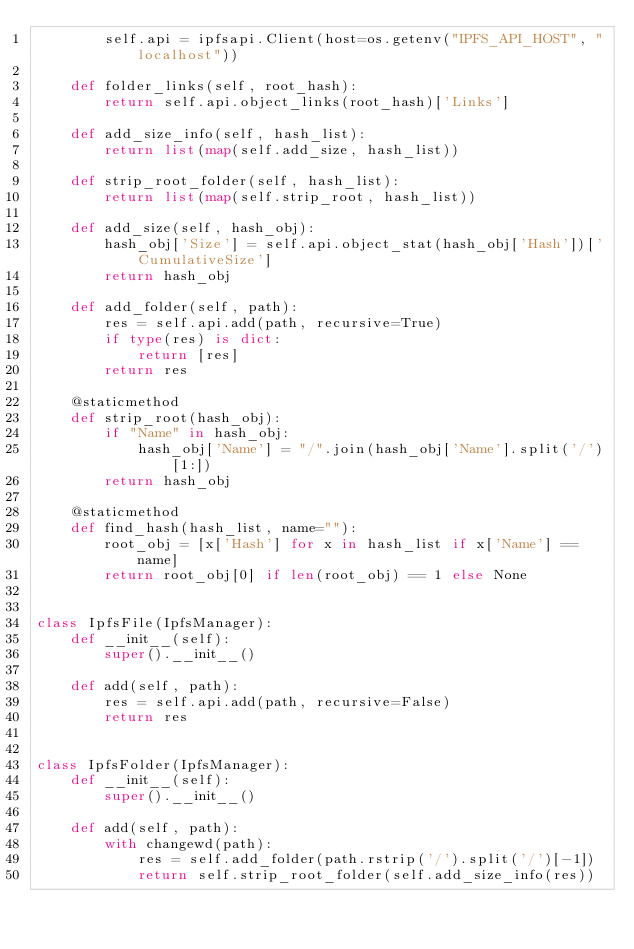Convert code to text. <code><loc_0><loc_0><loc_500><loc_500><_Python_>        self.api = ipfsapi.Client(host=os.getenv("IPFS_API_HOST", "localhost"))

    def folder_links(self, root_hash):
        return self.api.object_links(root_hash)['Links']

    def add_size_info(self, hash_list):
        return list(map(self.add_size, hash_list))

    def strip_root_folder(self, hash_list):
        return list(map(self.strip_root, hash_list))

    def add_size(self, hash_obj):
        hash_obj['Size'] = self.api.object_stat(hash_obj['Hash'])['CumulativeSize']
        return hash_obj

    def add_folder(self, path):
        res = self.api.add(path, recursive=True)
        if type(res) is dict:
            return [res]
        return res

    @staticmethod
    def strip_root(hash_obj):
        if "Name" in hash_obj:
            hash_obj['Name'] = "/".join(hash_obj['Name'].split('/')[1:])
        return hash_obj

    @staticmethod
    def find_hash(hash_list, name=""):
        root_obj = [x['Hash'] for x in hash_list if x['Name'] == name]
        return root_obj[0] if len(root_obj) == 1 else None


class IpfsFile(IpfsManager):
    def __init__(self):
        super().__init__()

    def add(self, path):
        res = self.api.add(path, recursive=False)
        return res


class IpfsFolder(IpfsManager):
    def __init__(self):
        super().__init__()

    def add(self, path):
        with changewd(path):
            res = self.add_folder(path.rstrip('/').split('/')[-1])
            return self.strip_root_folder(self.add_size_info(res))
</code> 